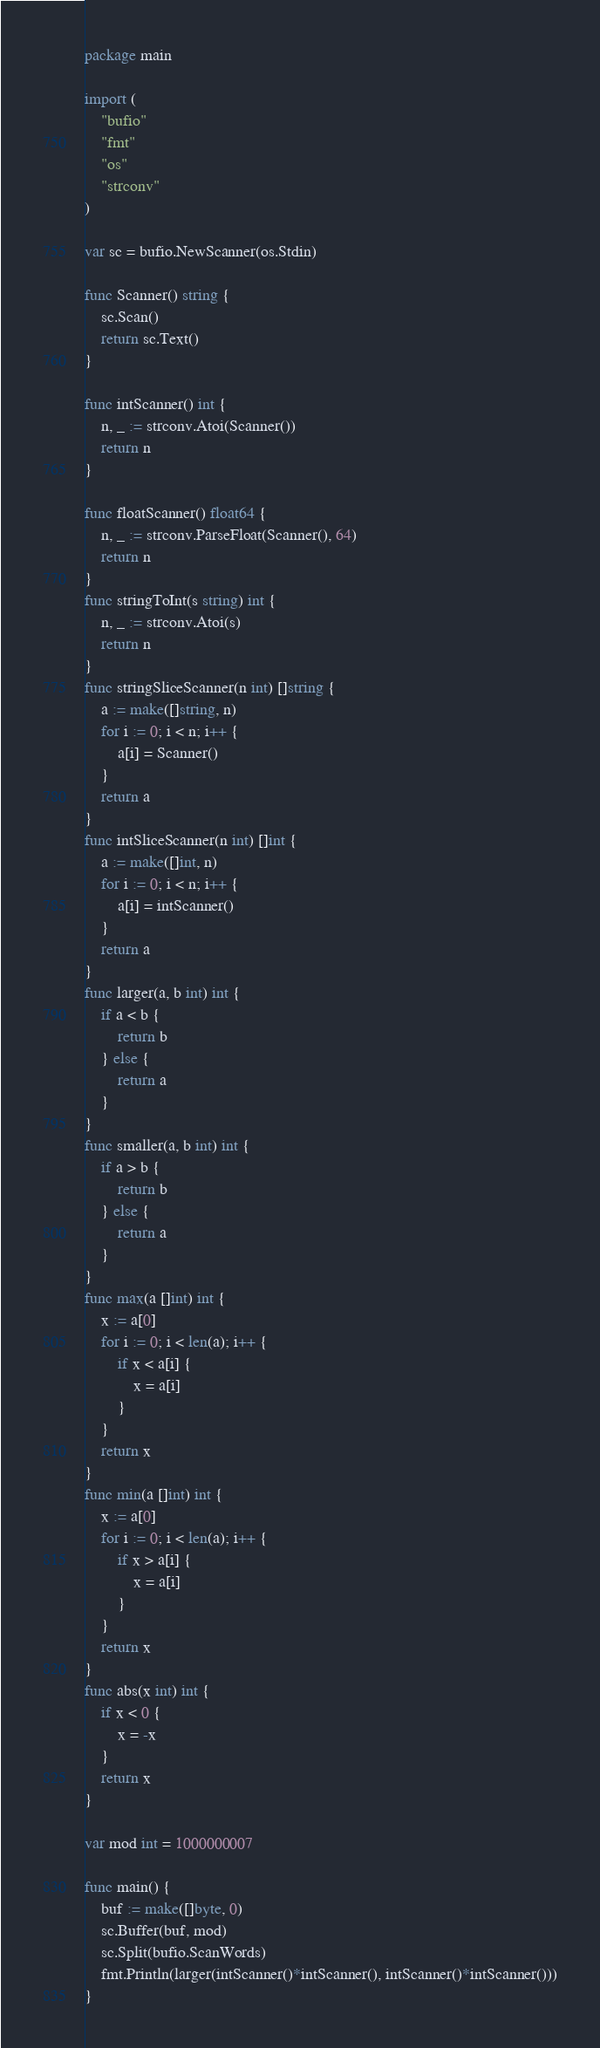<code> <loc_0><loc_0><loc_500><loc_500><_Go_>package main

import (
	"bufio"
	"fmt"
	"os"
	"strconv"
)

var sc = bufio.NewScanner(os.Stdin)

func Scanner() string {
	sc.Scan()
	return sc.Text()
}

func intScanner() int {
	n, _ := strconv.Atoi(Scanner())
	return n
}

func floatScanner() float64 {
	n, _ := strconv.ParseFloat(Scanner(), 64)
	return n
}
func stringToInt(s string) int {
	n, _ := strconv.Atoi(s)
	return n
}
func stringSliceScanner(n int) []string {
	a := make([]string, n)
	for i := 0; i < n; i++ {
		a[i] = Scanner()
	}
	return a
}
func intSliceScanner(n int) []int {
	a := make([]int, n)
	for i := 0; i < n; i++ {
		a[i] = intScanner()
	}
	return a
}
func larger(a, b int) int {
	if a < b {
		return b
	} else {
		return a
	}
}
func smaller(a, b int) int {
	if a > b {
		return b
	} else {
		return a
	}
}
func max(a []int) int {
	x := a[0]
	for i := 0; i < len(a); i++ {
		if x < a[i] {
			x = a[i]
		}
	}
	return x
}
func min(a []int) int {
	x := a[0]
	for i := 0; i < len(a); i++ {
		if x > a[i] {
			x = a[i]
		}
	}
	return x
}
func abs(x int) int {
	if x < 0 {
		x = -x
	}
	return x
}

var mod int = 1000000007

func main() {
	buf := make([]byte, 0)
	sc.Buffer(buf, mod)
	sc.Split(bufio.ScanWords)
	fmt.Println(larger(intScanner()*intScanner(), intScanner()*intScanner()))
}
</code> 